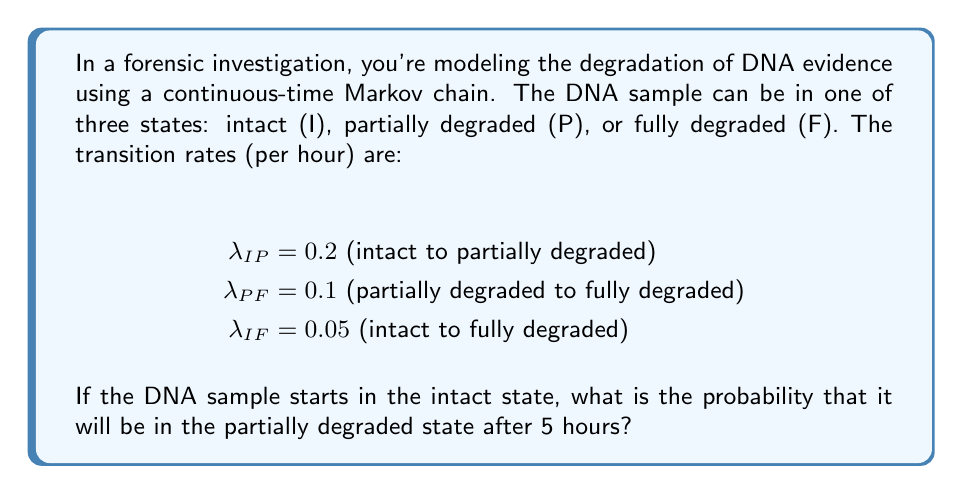Can you answer this question? To solve this problem, we'll use the Kolmogorov forward equations for a continuous-time Markov chain. Let $P_{ij}(t)$ be the probability of transitioning from state $i$ to state $j$ in time $t$.

1) First, we need to set up the generator matrix Q:

   $$Q = \begin{bmatrix}
   -(\lambda_{IP} + \lambda_{IF}) & \lambda_{IP} & \lambda_{IF} \\
   0 & -\lambda_{PF} & \lambda_{PF} \\
   0 & 0 & 0
   \end{bmatrix} = \begin{bmatrix}
   -0.25 & 0.2 & 0.05 \\
   0 & -0.1 & 0.1 \\
   0 & 0 & 0
   \end{bmatrix}$$

2) The solution to the Kolmogorov forward equations is given by:

   $$P(t) = e^{Qt}$$

3) To compute $e^{Qt}$, we can use the eigendecomposition method. The eigenvalues of Q are:

   $$\lambda_1 = -0.25, \lambda_2 = -0.1, \lambda_3 = 0$$

4) The corresponding eigenvectors form the matrix V:

   $$V = \begin{bmatrix}
   1 & 1 & 1 \\
   -\frac{4}{3} & 1 & 0 \\
   \frac{1}{3} & -1 & 1
   \end{bmatrix}$$

5) The diagonal matrix D of eigenvalues is:

   $$D = \begin{bmatrix}
   -0.25 & 0 & 0 \\
   0 & -0.1 & 0 \\
   0 & 0 & 0
   \end{bmatrix}$$

6) Now we can compute $e^{Qt} = Ve^{Dt}V^{-1}$:

   $$e^{Qt} = \begin{bmatrix}
   e^{-0.25t} & 0 & 0 \\
   \frac{4}{3}(e^{-0.25t} - e^{-0.1t}) & e^{-0.1t} & 0 \\
   1 - \frac{4}{3}e^{-0.25t} + \frac{1}{3}e^{-0.1t} & 1 - e^{-0.1t} & 1
   \end{bmatrix}$$

7) The probability we're looking for is $P_{IP}(5)$, which is the element at position (1,2) in the matrix $e^{Q5}$:

   $$P_{IP}(5) = \frac{4}{3}(e^{-0.25 \cdot 5} - e^{-0.1 \cdot 5}) \approx 0.3178$$

Thus, the probability that the DNA sample will be in the partially degraded state after 5 hours, given that it started in the intact state, is approximately 0.3178 or 31.78%.
Answer: 0.3178 